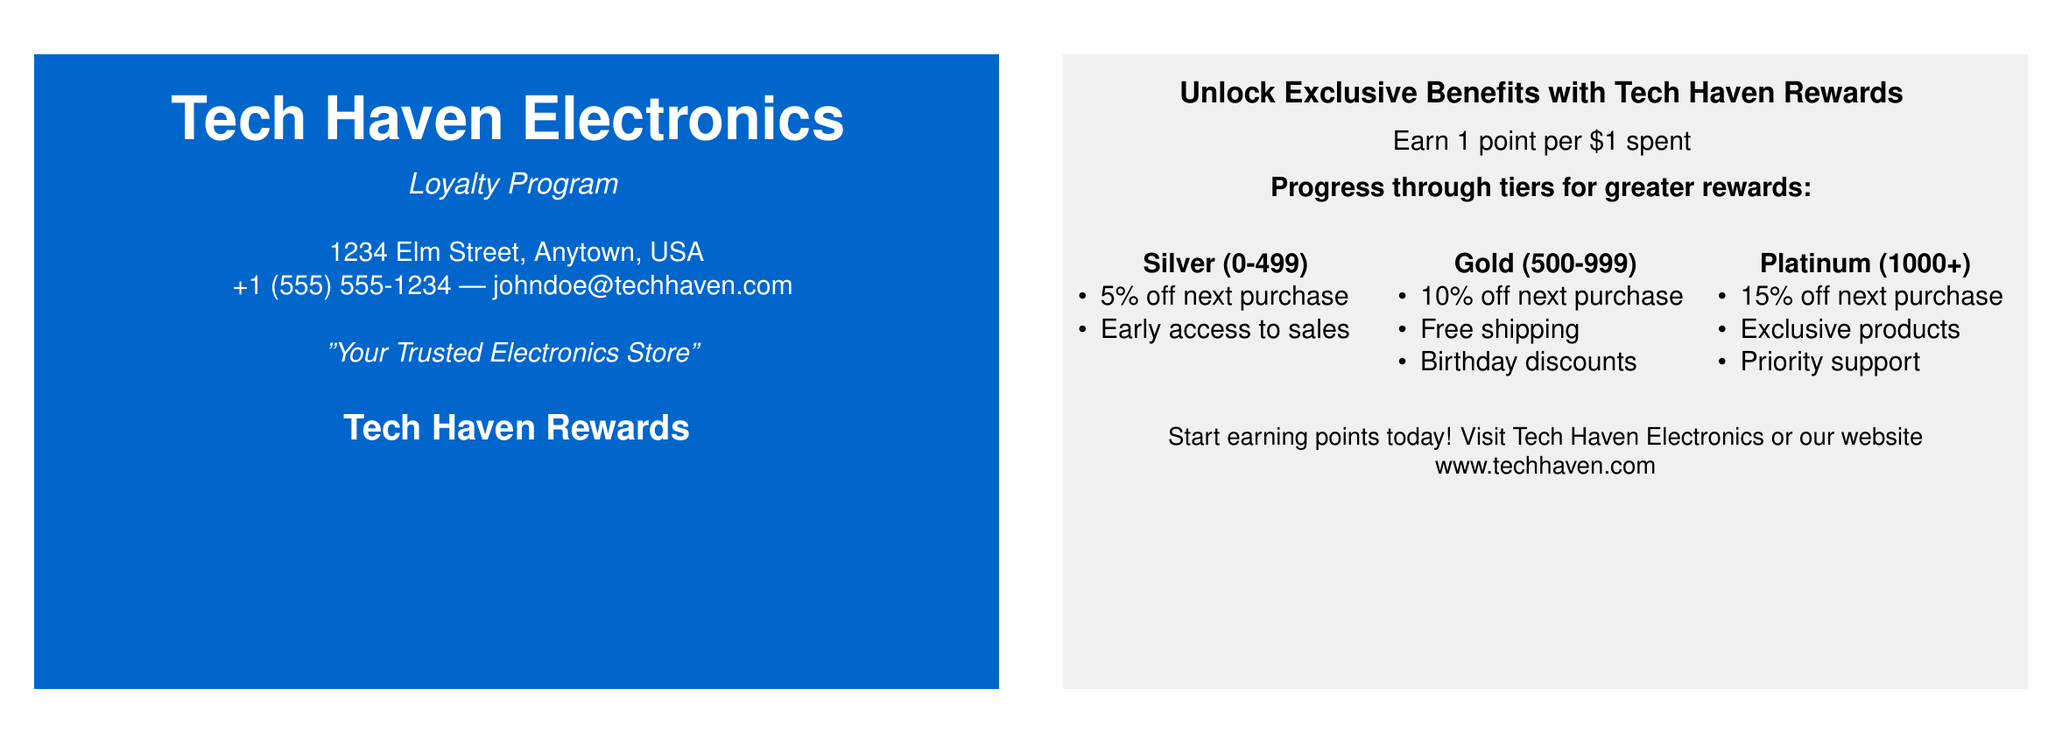what is the name of the electronics store? The name of the electronics store is highlighted prominently at the top of the business card.
Answer: Tech Haven Electronics what is the address of Tech Haven Electronics? The address is provided near the contact information on the card.
Answer: 1234 Elm Street, Anytown, USA how many points do you earn per dollar spent? The points earned per dollar spent are stated in the rewards program section of the document.
Answer: 1 point what tier requires 500 points? The tiers listed include thresholds for earning rewards, and this tier is specified.
Answer: Gold what discount do Platinum tier members receive on their next purchase? The rewards offered for each tier include specific discounts; this is mentioned for the Platinum tier.
Answer: 15% off what is one benefit of the Silver tier? The benefits for each tier include multiple offerings; this one is specifically mentioned for the Silver tier.
Answer: 5% off next purchase which tier offers free shipping? The tiers list specific benefits associated with them, including this for a certain tier.
Answer: Gold where can customers visit to start earning points? The document provides a call-to-action for customers regarding the loyalty program.
Answer: Tech Haven Electronics or our website www.techhaven.com what is the tagline for Tech Haven Electronics? The tagline is included as a motivational statement in the document.
Answer: Your Trusted Electronics Store 